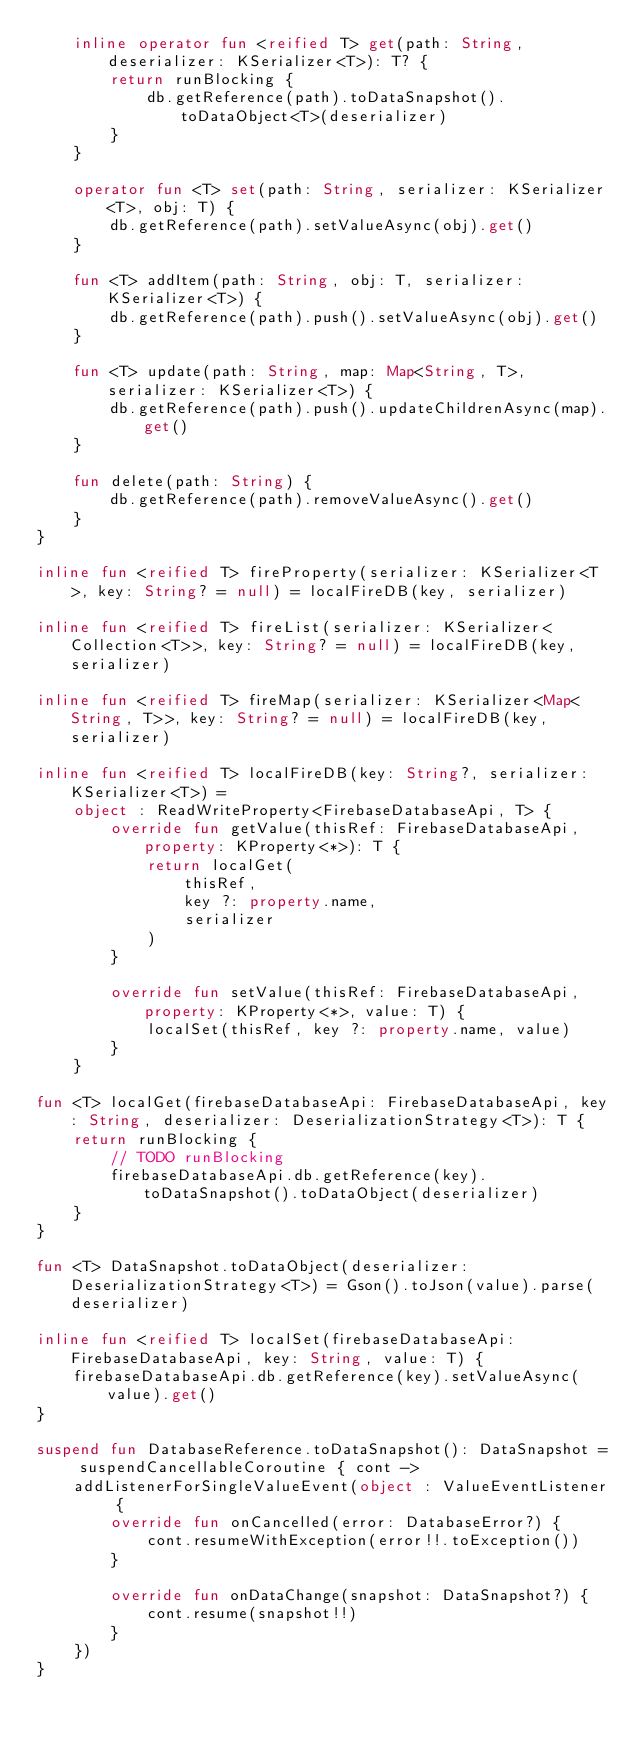Convert code to text. <code><loc_0><loc_0><loc_500><loc_500><_Kotlin_>    inline operator fun <reified T> get(path: String, deserializer: KSerializer<T>): T? {
        return runBlocking {
            db.getReference(path).toDataSnapshot().toDataObject<T>(deserializer)
        }
    }

    operator fun <T> set(path: String, serializer: KSerializer<T>, obj: T) {
        db.getReference(path).setValueAsync(obj).get()
    }

    fun <T> addItem(path: String, obj: T, serializer: KSerializer<T>) {
        db.getReference(path).push().setValueAsync(obj).get()
    }

    fun <T> update(path: String, map: Map<String, T>, serializer: KSerializer<T>) {
        db.getReference(path).push().updateChildrenAsync(map).get()
    }

    fun delete(path: String) {
        db.getReference(path).removeValueAsync().get()
    }
}

inline fun <reified T> fireProperty(serializer: KSerializer<T>, key: String? = null) = localFireDB(key, serializer)

inline fun <reified T> fireList(serializer: KSerializer<Collection<T>>, key: String? = null) = localFireDB(key, serializer)

inline fun <reified T> fireMap(serializer: KSerializer<Map<String, T>>, key: String? = null) = localFireDB(key, serializer)

inline fun <reified T> localFireDB(key: String?, serializer: KSerializer<T>) =
    object : ReadWriteProperty<FirebaseDatabaseApi, T> {
        override fun getValue(thisRef: FirebaseDatabaseApi, property: KProperty<*>): T {
            return localGet(
                thisRef,
                key ?: property.name,
                serializer
            )
        }

        override fun setValue(thisRef: FirebaseDatabaseApi, property: KProperty<*>, value: T) {
            localSet(thisRef, key ?: property.name, value)
        }
    }

fun <T> localGet(firebaseDatabaseApi: FirebaseDatabaseApi, key: String, deserializer: DeserializationStrategy<T>): T {
    return runBlocking {
        // TODO runBlocking
        firebaseDatabaseApi.db.getReference(key).toDataSnapshot().toDataObject(deserializer)
    }
}

fun <T> DataSnapshot.toDataObject(deserializer: DeserializationStrategy<T>) = Gson().toJson(value).parse(deserializer)

inline fun <reified T> localSet(firebaseDatabaseApi: FirebaseDatabaseApi, key: String, value: T) {
    firebaseDatabaseApi.db.getReference(key).setValueAsync(value).get()
}

suspend fun DatabaseReference.toDataSnapshot(): DataSnapshot = suspendCancellableCoroutine { cont ->
    addListenerForSingleValueEvent(object : ValueEventListener {
        override fun onCancelled(error: DatabaseError?) {
            cont.resumeWithException(error!!.toException())
        }

        override fun onDataChange(snapshot: DataSnapshot?) {
            cont.resume(snapshot!!)
        }
    })
}</code> 